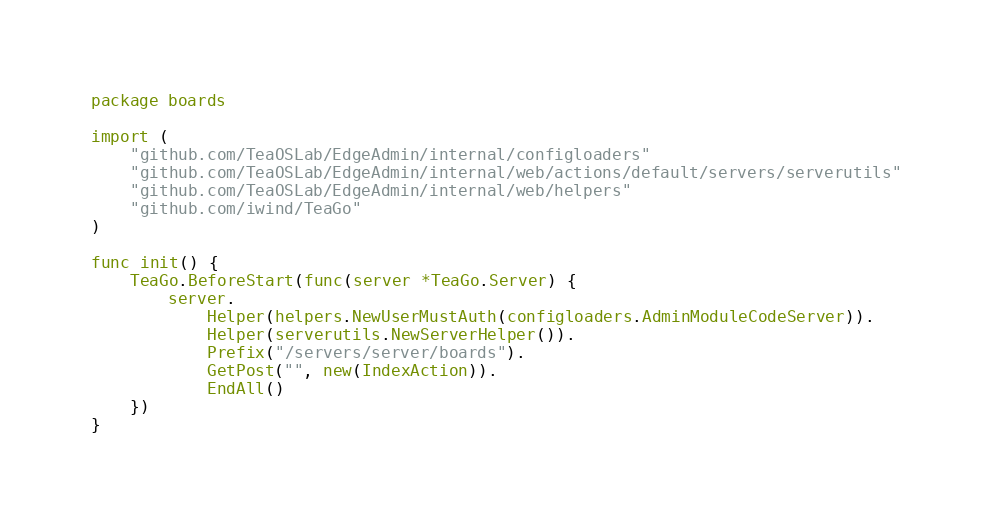Convert code to text. <code><loc_0><loc_0><loc_500><loc_500><_Go_>package boards

import (
	"github.com/TeaOSLab/EdgeAdmin/internal/configloaders"
	"github.com/TeaOSLab/EdgeAdmin/internal/web/actions/default/servers/serverutils"
	"github.com/TeaOSLab/EdgeAdmin/internal/web/helpers"
	"github.com/iwind/TeaGo"
)

func init() {
	TeaGo.BeforeStart(func(server *TeaGo.Server) {
		server.
			Helper(helpers.NewUserMustAuth(configloaders.AdminModuleCodeServer)).
			Helper(serverutils.NewServerHelper()).
			Prefix("/servers/server/boards").
			GetPost("", new(IndexAction)).
			EndAll()
	})
}
</code> 